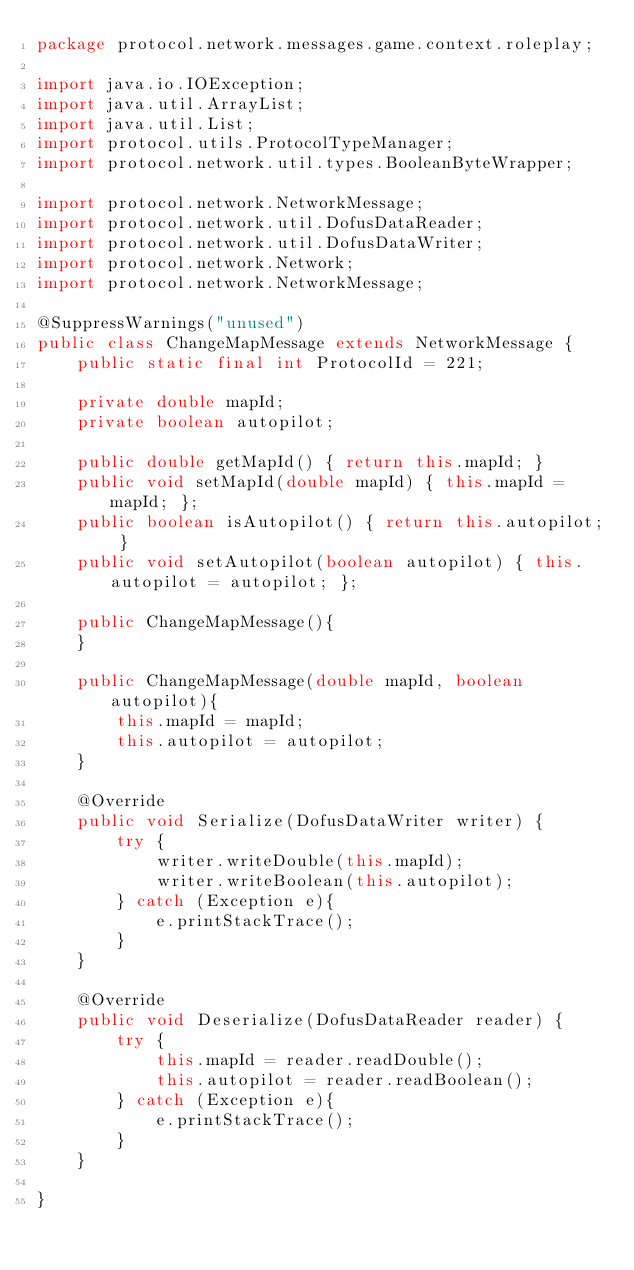<code> <loc_0><loc_0><loc_500><loc_500><_Java_>package protocol.network.messages.game.context.roleplay;

import java.io.IOException;
import java.util.ArrayList;
import java.util.List;
import protocol.utils.ProtocolTypeManager;
import protocol.network.util.types.BooleanByteWrapper;

import protocol.network.NetworkMessage;
import protocol.network.util.DofusDataReader;
import protocol.network.util.DofusDataWriter;
import protocol.network.Network;
import protocol.network.NetworkMessage;

@SuppressWarnings("unused")
public class ChangeMapMessage extends NetworkMessage {
	public static final int ProtocolId = 221;

	private double mapId;
	private boolean autopilot;

	public double getMapId() { return this.mapId; }
	public void setMapId(double mapId) { this.mapId = mapId; };
	public boolean isAutopilot() { return this.autopilot; }
	public void setAutopilot(boolean autopilot) { this.autopilot = autopilot; };

	public ChangeMapMessage(){
	}

	public ChangeMapMessage(double mapId, boolean autopilot){
		this.mapId = mapId;
		this.autopilot = autopilot;
	}

	@Override
	public void Serialize(DofusDataWriter writer) {
		try {
			writer.writeDouble(this.mapId);
			writer.writeBoolean(this.autopilot);
		} catch (Exception e){
			e.printStackTrace();
		}
	}

	@Override
	public void Deserialize(DofusDataReader reader) {
		try {
			this.mapId = reader.readDouble();
			this.autopilot = reader.readBoolean();
		} catch (Exception e){
			e.printStackTrace();
		}
	}

}
</code> 